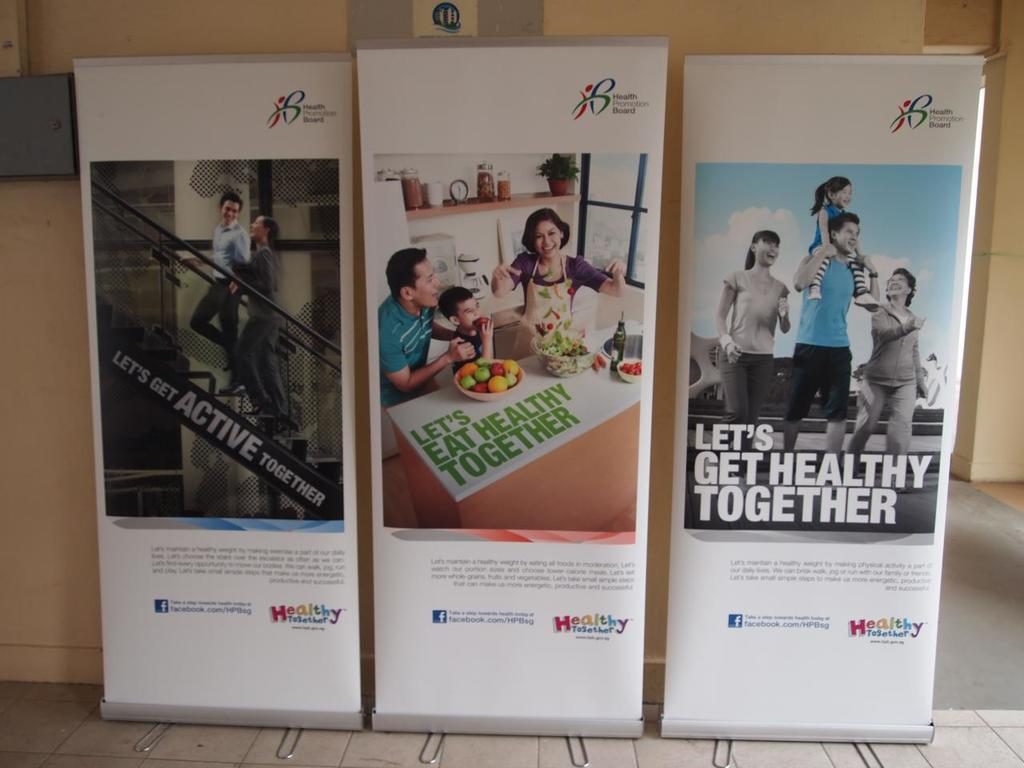<image>
Offer a succinct explanation of the picture presented. A trio of posters address subjects like being active with other people and being healthy with other people. 